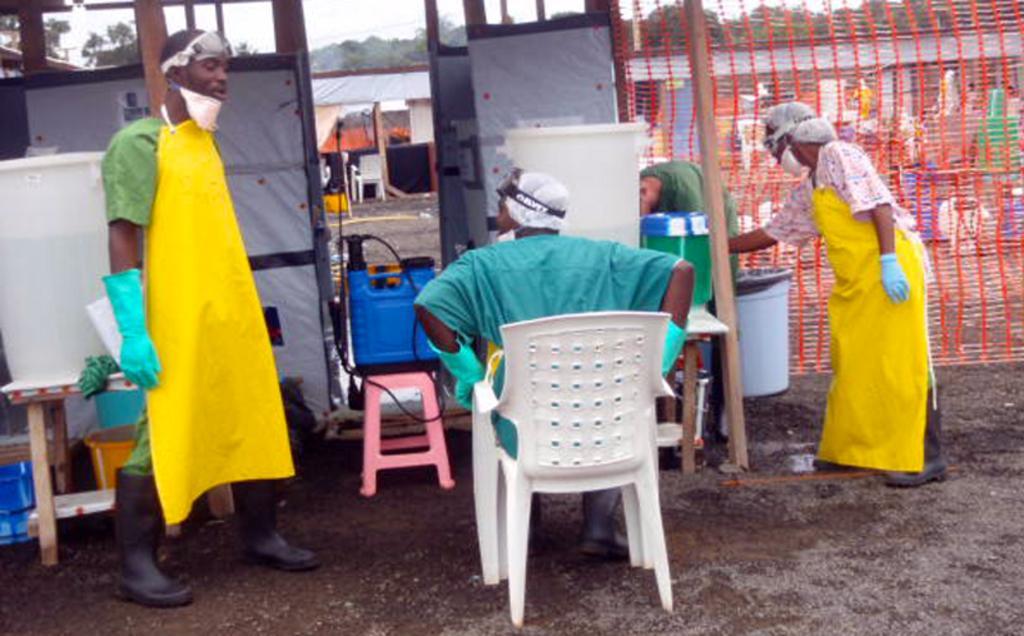How would you summarize this image in a sentence or two? In the image there is a man stood on left side and in middle a man sat and on right side there is a woman stood,it seems to be like a old station. 